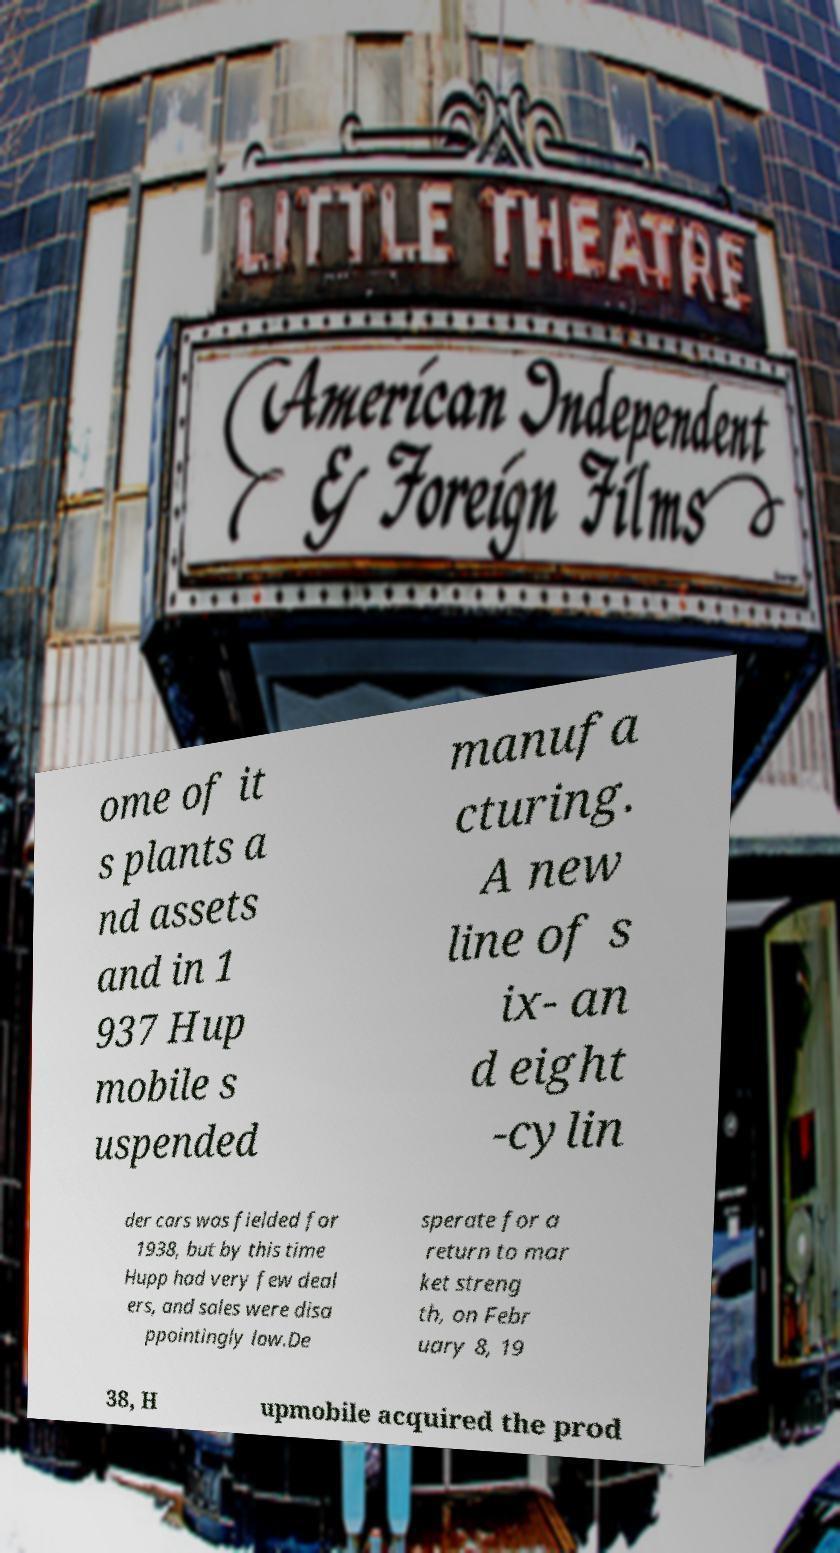Can you accurately transcribe the text from the provided image for me? ome of it s plants a nd assets and in 1 937 Hup mobile s uspended manufa cturing. A new line of s ix- an d eight -cylin der cars was fielded for 1938, but by this time Hupp had very few deal ers, and sales were disa ppointingly low.De sperate for a return to mar ket streng th, on Febr uary 8, 19 38, H upmobile acquired the prod 